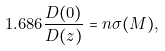Convert formula to latex. <formula><loc_0><loc_0><loc_500><loc_500>1 . 6 8 6 \frac { D ( 0 ) } { D ( z ) } = n \sigma ( M ) ,</formula> 